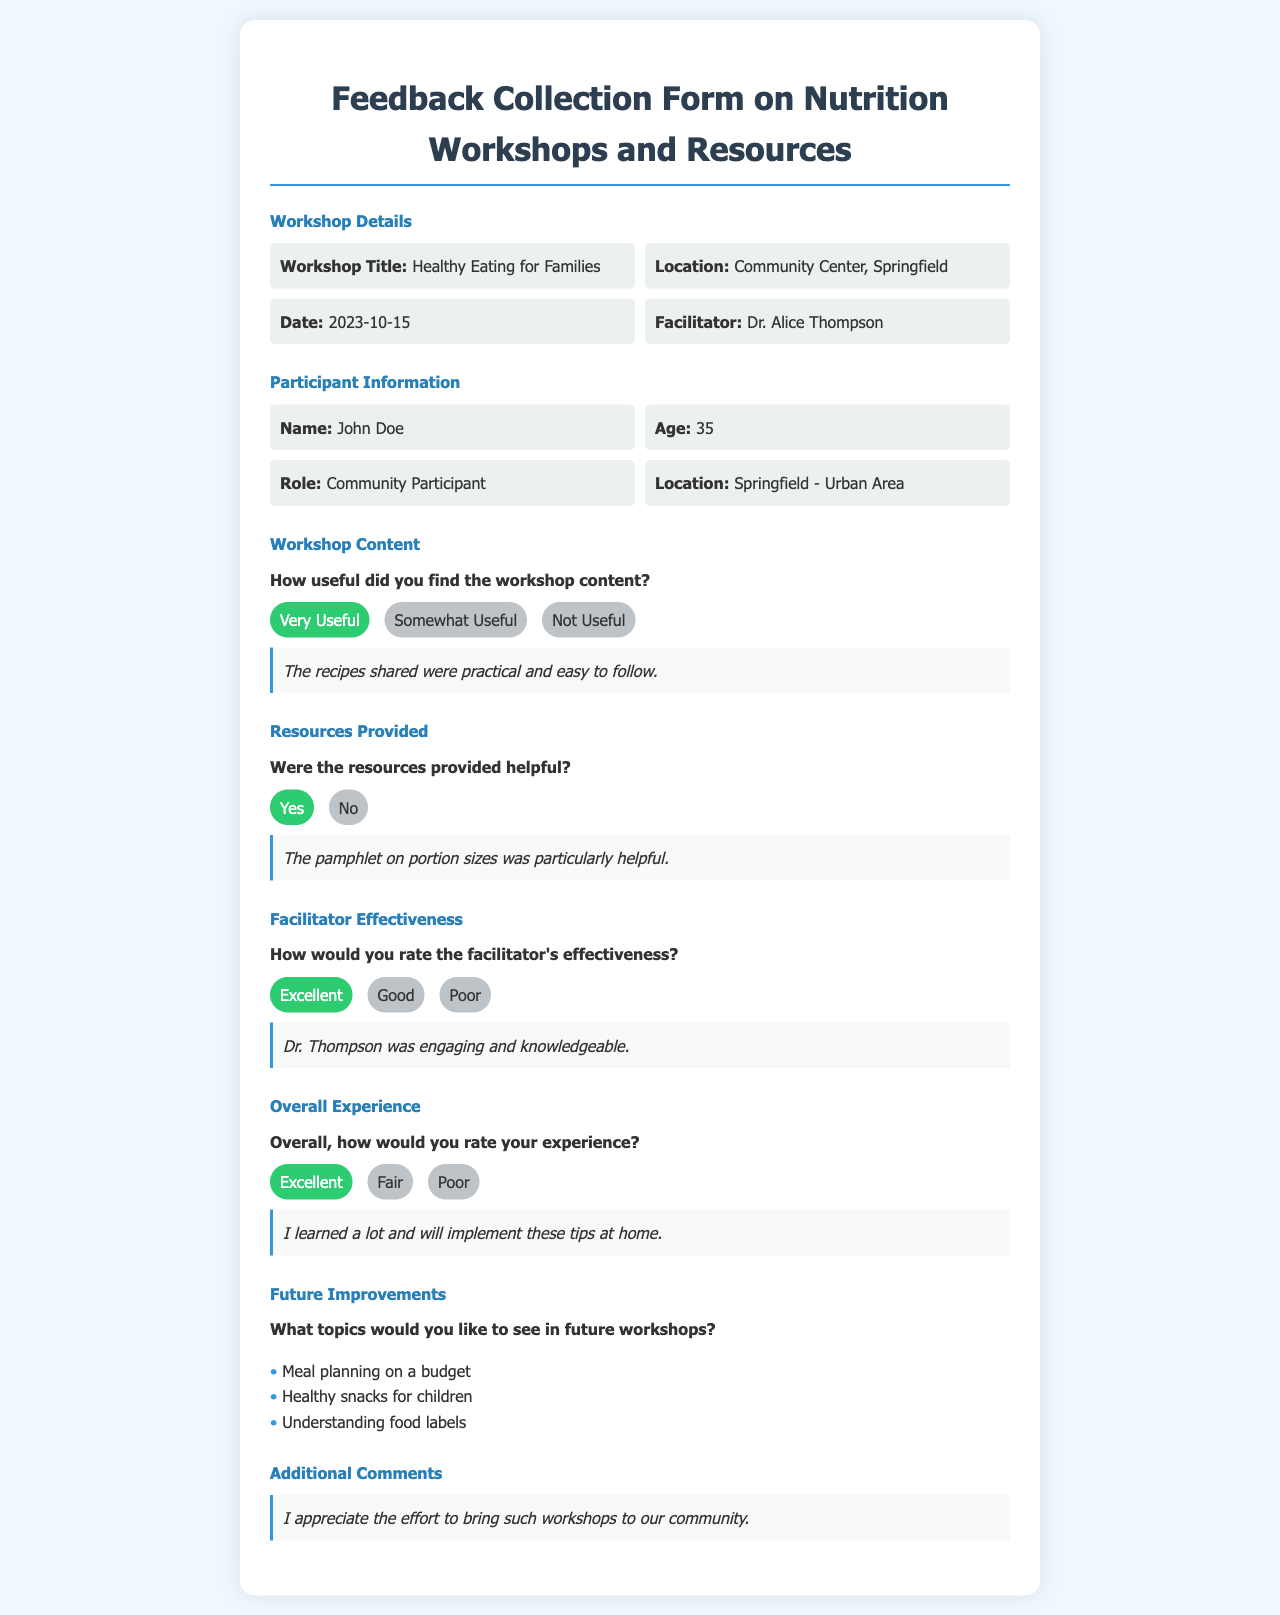What is the title of the workshop? The title of the workshop is stated in the Workshop Details section.
Answer: Healthy Eating for Families Who facilitated the workshop? The facilitator's name is mentioned in the Workshop Details section.
Answer: Dr. Alice Thompson What is the date of the workshop? The date of the workshop is provided in the Workshop Details section.
Answer: 2023-10-15 How did John Doe rate the workshop content? This rating is found in the Workshop Content section, reflecting John Doe's opinion.
Answer: Very Useful What resource was particularly helpful to the participant? This information is found in the Resources Provided section, noting a specific resource.
Answer: The pamphlet on portion sizes What topics did John Doe suggest for future workshops? This is listed in the Future Improvements section, highlighting participant suggestions.
Answer: Meal planning on a budget, Healthy snacks for children, Understanding food labels How would John Doe rate the facilitator's effectiveness? This rating is available in the Facilitator Effectiveness section, showing participant feedback.
Answer: Excellent What is the location of the workshop? The location is indicated in the Workshop Details section.
Answer: Community Center, Springfield 